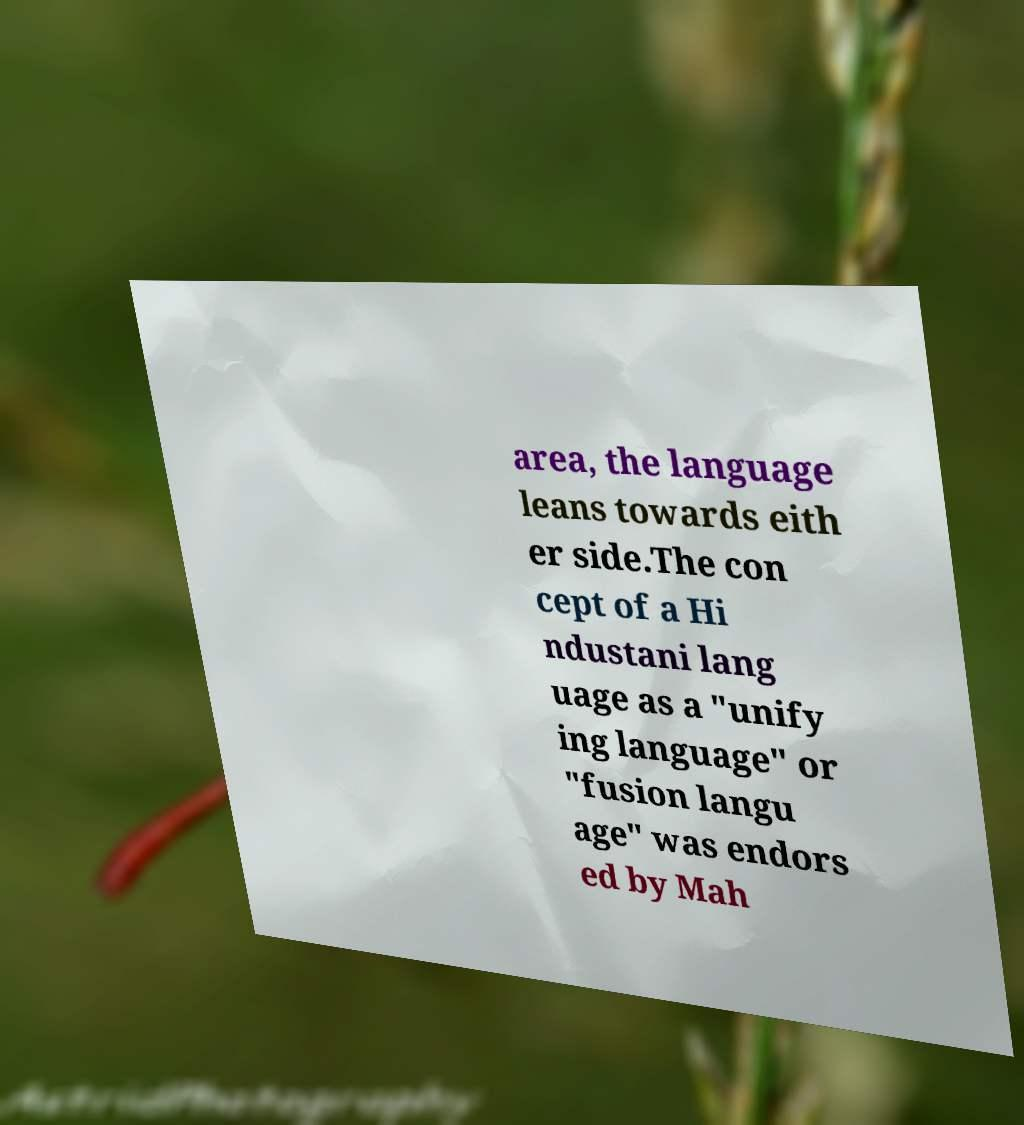Can you read and provide the text displayed in the image?This photo seems to have some interesting text. Can you extract and type it out for me? area, the language leans towards eith er side.The con cept of a Hi ndustani lang uage as a "unify ing language" or "fusion langu age" was endors ed by Mah 